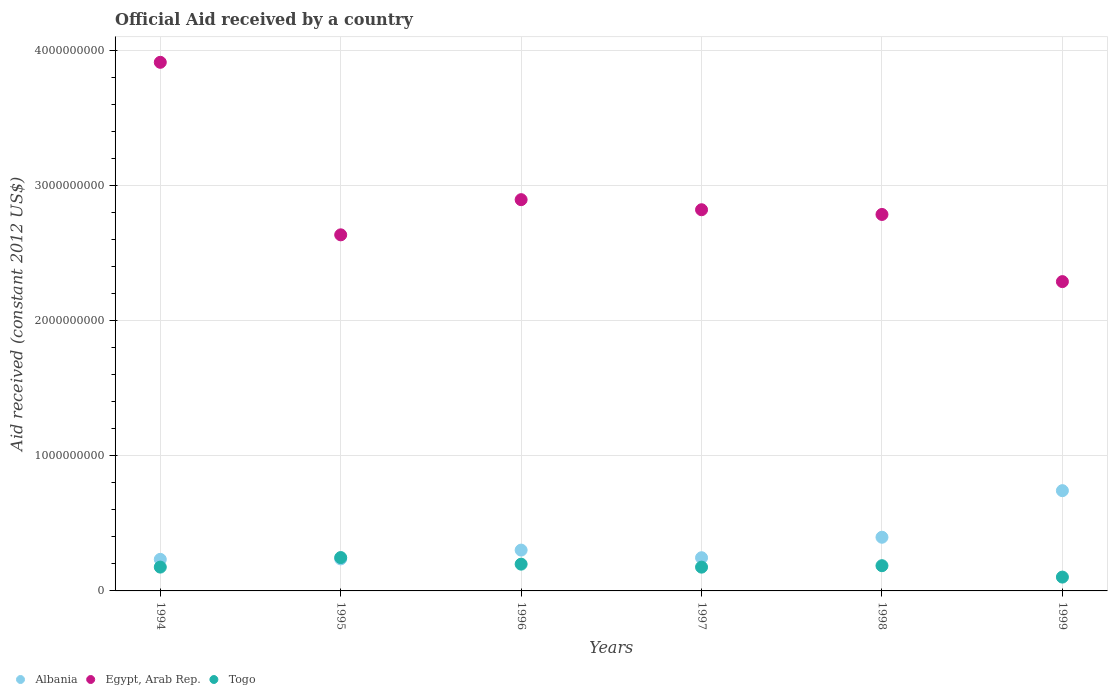How many different coloured dotlines are there?
Give a very brief answer. 3. What is the net official aid received in Togo in 1998?
Provide a short and direct response. 1.87e+08. Across all years, what is the maximum net official aid received in Egypt, Arab Rep.?
Your answer should be compact. 3.91e+09. Across all years, what is the minimum net official aid received in Albania?
Provide a short and direct response. 2.33e+08. In which year was the net official aid received in Albania maximum?
Ensure brevity in your answer.  1999. What is the total net official aid received in Egypt, Arab Rep. in the graph?
Give a very brief answer. 1.73e+1. What is the difference between the net official aid received in Togo in 1994 and that in 1995?
Make the answer very short. -7.06e+07. What is the difference between the net official aid received in Togo in 1997 and the net official aid received in Egypt, Arab Rep. in 1999?
Offer a very short reply. -2.11e+09. What is the average net official aid received in Albania per year?
Offer a very short reply. 3.59e+08. In the year 1994, what is the difference between the net official aid received in Albania and net official aid received in Egypt, Arab Rep.?
Offer a terse response. -3.68e+09. In how many years, is the net official aid received in Albania greater than 1600000000 US$?
Your answer should be compact. 0. What is the ratio of the net official aid received in Albania in 1997 to that in 1998?
Offer a very short reply. 0.62. Is the net official aid received in Egypt, Arab Rep. in 1995 less than that in 1999?
Provide a short and direct response. No. Is the difference between the net official aid received in Albania in 1995 and 1999 greater than the difference between the net official aid received in Egypt, Arab Rep. in 1995 and 1999?
Give a very brief answer. No. What is the difference between the highest and the second highest net official aid received in Egypt, Arab Rep.?
Offer a very short reply. 1.02e+09. What is the difference between the highest and the lowest net official aid received in Togo?
Your response must be concise. 1.44e+08. Is the sum of the net official aid received in Albania in 1995 and 1996 greater than the maximum net official aid received in Togo across all years?
Offer a terse response. Yes. Is it the case that in every year, the sum of the net official aid received in Albania and net official aid received in Egypt, Arab Rep.  is greater than the net official aid received in Togo?
Provide a short and direct response. Yes. Is the net official aid received in Egypt, Arab Rep. strictly greater than the net official aid received in Albania over the years?
Ensure brevity in your answer.  Yes. How many dotlines are there?
Offer a very short reply. 3. How many years are there in the graph?
Give a very brief answer. 6. Are the values on the major ticks of Y-axis written in scientific E-notation?
Your response must be concise. No. Does the graph contain any zero values?
Give a very brief answer. No. Does the graph contain grids?
Give a very brief answer. Yes. How many legend labels are there?
Provide a short and direct response. 3. How are the legend labels stacked?
Your response must be concise. Horizontal. What is the title of the graph?
Give a very brief answer. Official Aid received by a country. What is the label or title of the X-axis?
Make the answer very short. Years. What is the label or title of the Y-axis?
Ensure brevity in your answer.  Aid received (constant 2012 US$). What is the Aid received (constant 2012 US$) of Albania in 1994?
Your answer should be compact. 2.33e+08. What is the Aid received (constant 2012 US$) of Egypt, Arab Rep. in 1994?
Provide a short and direct response. 3.91e+09. What is the Aid received (constant 2012 US$) of Togo in 1994?
Your answer should be compact. 1.76e+08. What is the Aid received (constant 2012 US$) of Albania in 1995?
Offer a very short reply. 2.37e+08. What is the Aid received (constant 2012 US$) in Egypt, Arab Rep. in 1995?
Offer a very short reply. 2.63e+09. What is the Aid received (constant 2012 US$) in Togo in 1995?
Offer a terse response. 2.47e+08. What is the Aid received (constant 2012 US$) in Albania in 1996?
Provide a short and direct response. 3.02e+08. What is the Aid received (constant 2012 US$) in Egypt, Arab Rep. in 1996?
Make the answer very short. 2.89e+09. What is the Aid received (constant 2012 US$) in Togo in 1996?
Offer a terse response. 1.98e+08. What is the Aid received (constant 2012 US$) in Albania in 1997?
Make the answer very short. 2.46e+08. What is the Aid received (constant 2012 US$) of Egypt, Arab Rep. in 1997?
Your answer should be compact. 2.82e+09. What is the Aid received (constant 2012 US$) of Togo in 1997?
Ensure brevity in your answer.  1.76e+08. What is the Aid received (constant 2012 US$) in Albania in 1998?
Give a very brief answer. 3.97e+08. What is the Aid received (constant 2012 US$) in Egypt, Arab Rep. in 1998?
Your response must be concise. 2.78e+09. What is the Aid received (constant 2012 US$) of Togo in 1998?
Your answer should be very brief. 1.87e+08. What is the Aid received (constant 2012 US$) of Albania in 1999?
Offer a very short reply. 7.41e+08. What is the Aid received (constant 2012 US$) in Egypt, Arab Rep. in 1999?
Offer a terse response. 2.29e+09. What is the Aid received (constant 2012 US$) in Togo in 1999?
Keep it short and to the point. 1.02e+08. Across all years, what is the maximum Aid received (constant 2012 US$) in Albania?
Keep it short and to the point. 7.41e+08. Across all years, what is the maximum Aid received (constant 2012 US$) in Egypt, Arab Rep.?
Your answer should be very brief. 3.91e+09. Across all years, what is the maximum Aid received (constant 2012 US$) of Togo?
Your answer should be very brief. 2.47e+08. Across all years, what is the minimum Aid received (constant 2012 US$) of Albania?
Offer a very short reply. 2.33e+08. Across all years, what is the minimum Aid received (constant 2012 US$) in Egypt, Arab Rep.?
Make the answer very short. 2.29e+09. Across all years, what is the minimum Aid received (constant 2012 US$) in Togo?
Your answer should be compact. 1.02e+08. What is the total Aid received (constant 2012 US$) in Albania in the graph?
Your answer should be very brief. 2.16e+09. What is the total Aid received (constant 2012 US$) of Egypt, Arab Rep. in the graph?
Offer a terse response. 1.73e+1. What is the total Aid received (constant 2012 US$) in Togo in the graph?
Offer a very short reply. 1.09e+09. What is the difference between the Aid received (constant 2012 US$) of Albania in 1994 and that in 1995?
Provide a short and direct response. -3.44e+06. What is the difference between the Aid received (constant 2012 US$) in Egypt, Arab Rep. in 1994 and that in 1995?
Give a very brief answer. 1.28e+09. What is the difference between the Aid received (constant 2012 US$) of Togo in 1994 and that in 1995?
Offer a very short reply. -7.06e+07. What is the difference between the Aid received (constant 2012 US$) of Albania in 1994 and that in 1996?
Provide a succinct answer. -6.84e+07. What is the difference between the Aid received (constant 2012 US$) in Egypt, Arab Rep. in 1994 and that in 1996?
Offer a very short reply. 1.02e+09. What is the difference between the Aid received (constant 2012 US$) in Togo in 1994 and that in 1996?
Provide a short and direct response. -2.18e+07. What is the difference between the Aid received (constant 2012 US$) of Albania in 1994 and that in 1997?
Your answer should be very brief. -1.21e+07. What is the difference between the Aid received (constant 2012 US$) of Egypt, Arab Rep. in 1994 and that in 1997?
Provide a short and direct response. 1.09e+09. What is the difference between the Aid received (constant 2012 US$) of Albania in 1994 and that in 1998?
Offer a terse response. -1.64e+08. What is the difference between the Aid received (constant 2012 US$) in Egypt, Arab Rep. in 1994 and that in 1998?
Offer a very short reply. 1.13e+09. What is the difference between the Aid received (constant 2012 US$) in Togo in 1994 and that in 1998?
Provide a short and direct response. -1.04e+07. What is the difference between the Aid received (constant 2012 US$) in Albania in 1994 and that in 1999?
Provide a short and direct response. -5.08e+08. What is the difference between the Aid received (constant 2012 US$) in Egypt, Arab Rep. in 1994 and that in 1999?
Ensure brevity in your answer.  1.62e+09. What is the difference between the Aid received (constant 2012 US$) of Togo in 1994 and that in 1999?
Provide a succinct answer. 7.39e+07. What is the difference between the Aid received (constant 2012 US$) in Albania in 1995 and that in 1996?
Offer a very short reply. -6.50e+07. What is the difference between the Aid received (constant 2012 US$) of Egypt, Arab Rep. in 1995 and that in 1996?
Offer a terse response. -2.60e+08. What is the difference between the Aid received (constant 2012 US$) in Togo in 1995 and that in 1996?
Keep it short and to the point. 4.87e+07. What is the difference between the Aid received (constant 2012 US$) in Albania in 1995 and that in 1997?
Ensure brevity in your answer.  -8.68e+06. What is the difference between the Aid received (constant 2012 US$) in Egypt, Arab Rep. in 1995 and that in 1997?
Offer a terse response. -1.86e+08. What is the difference between the Aid received (constant 2012 US$) of Togo in 1995 and that in 1997?
Provide a succinct answer. 7.09e+07. What is the difference between the Aid received (constant 2012 US$) of Albania in 1995 and that in 1998?
Provide a short and direct response. -1.60e+08. What is the difference between the Aid received (constant 2012 US$) of Egypt, Arab Rep. in 1995 and that in 1998?
Make the answer very short. -1.51e+08. What is the difference between the Aid received (constant 2012 US$) of Togo in 1995 and that in 1998?
Keep it short and to the point. 6.02e+07. What is the difference between the Aid received (constant 2012 US$) in Albania in 1995 and that in 1999?
Your response must be concise. -5.05e+08. What is the difference between the Aid received (constant 2012 US$) of Egypt, Arab Rep. in 1995 and that in 1999?
Offer a terse response. 3.46e+08. What is the difference between the Aid received (constant 2012 US$) in Togo in 1995 and that in 1999?
Ensure brevity in your answer.  1.44e+08. What is the difference between the Aid received (constant 2012 US$) in Albania in 1996 and that in 1997?
Ensure brevity in your answer.  5.63e+07. What is the difference between the Aid received (constant 2012 US$) in Egypt, Arab Rep. in 1996 and that in 1997?
Your answer should be very brief. 7.45e+07. What is the difference between the Aid received (constant 2012 US$) in Togo in 1996 and that in 1997?
Ensure brevity in your answer.  2.22e+07. What is the difference between the Aid received (constant 2012 US$) in Albania in 1996 and that in 1998?
Your answer should be very brief. -9.51e+07. What is the difference between the Aid received (constant 2012 US$) in Egypt, Arab Rep. in 1996 and that in 1998?
Your answer should be very brief. 1.09e+08. What is the difference between the Aid received (constant 2012 US$) of Togo in 1996 and that in 1998?
Make the answer very short. 1.15e+07. What is the difference between the Aid received (constant 2012 US$) of Albania in 1996 and that in 1999?
Give a very brief answer. -4.40e+08. What is the difference between the Aid received (constant 2012 US$) of Egypt, Arab Rep. in 1996 and that in 1999?
Provide a succinct answer. 6.06e+08. What is the difference between the Aid received (constant 2012 US$) in Togo in 1996 and that in 1999?
Offer a terse response. 9.57e+07. What is the difference between the Aid received (constant 2012 US$) of Albania in 1997 and that in 1998?
Your response must be concise. -1.51e+08. What is the difference between the Aid received (constant 2012 US$) in Egypt, Arab Rep. in 1997 and that in 1998?
Provide a succinct answer. 3.49e+07. What is the difference between the Aid received (constant 2012 US$) of Togo in 1997 and that in 1998?
Ensure brevity in your answer.  -1.07e+07. What is the difference between the Aid received (constant 2012 US$) of Albania in 1997 and that in 1999?
Your answer should be very brief. -4.96e+08. What is the difference between the Aid received (constant 2012 US$) in Egypt, Arab Rep. in 1997 and that in 1999?
Keep it short and to the point. 5.32e+08. What is the difference between the Aid received (constant 2012 US$) in Togo in 1997 and that in 1999?
Provide a short and direct response. 7.36e+07. What is the difference between the Aid received (constant 2012 US$) in Albania in 1998 and that in 1999?
Your response must be concise. -3.44e+08. What is the difference between the Aid received (constant 2012 US$) in Egypt, Arab Rep. in 1998 and that in 1999?
Provide a short and direct response. 4.97e+08. What is the difference between the Aid received (constant 2012 US$) in Togo in 1998 and that in 1999?
Provide a short and direct response. 8.43e+07. What is the difference between the Aid received (constant 2012 US$) of Albania in 1994 and the Aid received (constant 2012 US$) of Egypt, Arab Rep. in 1995?
Provide a succinct answer. -2.40e+09. What is the difference between the Aid received (constant 2012 US$) in Albania in 1994 and the Aid received (constant 2012 US$) in Togo in 1995?
Your response must be concise. -1.33e+07. What is the difference between the Aid received (constant 2012 US$) in Egypt, Arab Rep. in 1994 and the Aid received (constant 2012 US$) in Togo in 1995?
Your answer should be compact. 3.66e+09. What is the difference between the Aid received (constant 2012 US$) in Albania in 1994 and the Aid received (constant 2012 US$) in Egypt, Arab Rep. in 1996?
Provide a succinct answer. -2.66e+09. What is the difference between the Aid received (constant 2012 US$) in Albania in 1994 and the Aid received (constant 2012 US$) in Togo in 1996?
Keep it short and to the point. 3.54e+07. What is the difference between the Aid received (constant 2012 US$) in Egypt, Arab Rep. in 1994 and the Aid received (constant 2012 US$) in Togo in 1996?
Your answer should be compact. 3.71e+09. What is the difference between the Aid received (constant 2012 US$) of Albania in 1994 and the Aid received (constant 2012 US$) of Egypt, Arab Rep. in 1997?
Your answer should be compact. -2.59e+09. What is the difference between the Aid received (constant 2012 US$) in Albania in 1994 and the Aid received (constant 2012 US$) in Togo in 1997?
Make the answer very short. 5.76e+07. What is the difference between the Aid received (constant 2012 US$) in Egypt, Arab Rep. in 1994 and the Aid received (constant 2012 US$) in Togo in 1997?
Your answer should be very brief. 3.73e+09. What is the difference between the Aid received (constant 2012 US$) of Albania in 1994 and the Aid received (constant 2012 US$) of Egypt, Arab Rep. in 1998?
Provide a succinct answer. -2.55e+09. What is the difference between the Aid received (constant 2012 US$) of Albania in 1994 and the Aid received (constant 2012 US$) of Togo in 1998?
Your answer should be compact. 4.69e+07. What is the difference between the Aid received (constant 2012 US$) in Egypt, Arab Rep. in 1994 and the Aid received (constant 2012 US$) in Togo in 1998?
Keep it short and to the point. 3.72e+09. What is the difference between the Aid received (constant 2012 US$) in Albania in 1994 and the Aid received (constant 2012 US$) in Egypt, Arab Rep. in 1999?
Provide a succinct answer. -2.05e+09. What is the difference between the Aid received (constant 2012 US$) of Albania in 1994 and the Aid received (constant 2012 US$) of Togo in 1999?
Give a very brief answer. 1.31e+08. What is the difference between the Aid received (constant 2012 US$) of Egypt, Arab Rep. in 1994 and the Aid received (constant 2012 US$) of Togo in 1999?
Offer a very short reply. 3.81e+09. What is the difference between the Aid received (constant 2012 US$) of Albania in 1995 and the Aid received (constant 2012 US$) of Egypt, Arab Rep. in 1996?
Your answer should be compact. -2.66e+09. What is the difference between the Aid received (constant 2012 US$) of Albania in 1995 and the Aid received (constant 2012 US$) of Togo in 1996?
Provide a succinct answer. 3.88e+07. What is the difference between the Aid received (constant 2012 US$) of Egypt, Arab Rep. in 1995 and the Aid received (constant 2012 US$) of Togo in 1996?
Give a very brief answer. 2.44e+09. What is the difference between the Aid received (constant 2012 US$) in Albania in 1995 and the Aid received (constant 2012 US$) in Egypt, Arab Rep. in 1997?
Give a very brief answer. -2.58e+09. What is the difference between the Aid received (constant 2012 US$) in Albania in 1995 and the Aid received (constant 2012 US$) in Togo in 1997?
Your answer should be compact. 6.10e+07. What is the difference between the Aid received (constant 2012 US$) in Egypt, Arab Rep. in 1995 and the Aid received (constant 2012 US$) in Togo in 1997?
Keep it short and to the point. 2.46e+09. What is the difference between the Aid received (constant 2012 US$) of Albania in 1995 and the Aid received (constant 2012 US$) of Egypt, Arab Rep. in 1998?
Provide a succinct answer. -2.55e+09. What is the difference between the Aid received (constant 2012 US$) in Albania in 1995 and the Aid received (constant 2012 US$) in Togo in 1998?
Make the answer very short. 5.03e+07. What is the difference between the Aid received (constant 2012 US$) of Egypt, Arab Rep. in 1995 and the Aid received (constant 2012 US$) of Togo in 1998?
Your answer should be very brief. 2.45e+09. What is the difference between the Aid received (constant 2012 US$) in Albania in 1995 and the Aid received (constant 2012 US$) in Egypt, Arab Rep. in 1999?
Ensure brevity in your answer.  -2.05e+09. What is the difference between the Aid received (constant 2012 US$) of Albania in 1995 and the Aid received (constant 2012 US$) of Togo in 1999?
Offer a terse response. 1.35e+08. What is the difference between the Aid received (constant 2012 US$) in Egypt, Arab Rep. in 1995 and the Aid received (constant 2012 US$) in Togo in 1999?
Provide a short and direct response. 2.53e+09. What is the difference between the Aid received (constant 2012 US$) in Albania in 1996 and the Aid received (constant 2012 US$) in Egypt, Arab Rep. in 1997?
Your answer should be very brief. -2.52e+09. What is the difference between the Aid received (constant 2012 US$) of Albania in 1996 and the Aid received (constant 2012 US$) of Togo in 1997?
Offer a very short reply. 1.26e+08. What is the difference between the Aid received (constant 2012 US$) of Egypt, Arab Rep. in 1996 and the Aid received (constant 2012 US$) of Togo in 1997?
Give a very brief answer. 2.72e+09. What is the difference between the Aid received (constant 2012 US$) of Albania in 1996 and the Aid received (constant 2012 US$) of Egypt, Arab Rep. in 1998?
Offer a terse response. -2.48e+09. What is the difference between the Aid received (constant 2012 US$) of Albania in 1996 and the Aid received (constant 2012 US$) of Togo in 1998?
Offer a very short reply. 1.15e+08. What is the difference between the Aid received (constant 2012 US$) of Egypt, Arab Rep. in 1996 and the Aid received (constant 2012 US$) of Togo in 1998?
Give a very brief answer. 2.71e+09. What is the difference between the Aid received (constant 2012 US$) in Albania in 1996 and the Aid received (constant 2012 US$) in Egypt, Arab Rep. in 1999?
Your response must be concise. -1.99e+09. What is the difference between the Aid received (constant 2012 US$) of Albania in 1996 and the Aid received (constant 2012 US$) of Togo in 1999?
Your answer should be compact. 2.00e+08. What is the difference between the Aid received (constant 2012 US$) of Egypt, Arab Rep. in 1996 and the Aid received (constant 2012 US$) of Togo in 1999?
Offer a terse response. 2.79e+09. What is the difference between the Aid received (constant 2012 US$) of Albania in 1997 and the Aid received (constant 2012 US$) of Egypt, Arab Rep. in 1998?
Give a very brief answer. -2.54e+09. What is the difference between the Aid received (constant 2012 US$) of Albania in 1997 and the Aid received (constant 2012 US$) of Togo in 1998?
Offer a very short reply. 5.90e+07. What is the difference between the Aid received (constant 2012 US$) of Egypt, Arab Rep. in 1997 and the Aid received (constant 2012 US$) of Togo in 1998?
Your answer should be very brief. 2.63e+09. What is the difference between the Aid received (constant 2012 US$) in Albania in 1997 and the Aid received (constant 2012 US$) in Egypt, Arab Rep. in 1999?
Ensure brevity in your answer.  -2.04e+09. What is the difference between the Aid received (constant 2012 US$) in Albania in 1997 and the Aid received (constant 2012 US$) in Togo in 1999?
Keep it short and to the point. 1.43e+08. What is the difference between the Aid received (constant 2012 US$) in Egypt, Arab Rep. in 1997 and the Aid received (constant 2012 US$) in Togo in 1999?
Provide a short and direct response. 2.72e+09. What is the difference between the Aid received (constant 2012 US$) of Albania in 1998 and the Aid received (constant 2012 US$) of Egypt, Arab Rep. in 1999?
Provide a succinct answer. -1.89e+09. What is the difference between the Aid received (constant 2012 US$) in Albania in 1998 and the Aid received (constant 2012 US$) in Togo in 1999?
Make the answer very short. 2.95e+08. What is the difference between the Aid received (constant 2012 US$) in Egypt, Arab Rep. in 1998 and the Aid received (constant 2012 US$) in Togo in 1999?
Offer a very short reply. 2.68e+09. What is the average Aid received (constant 2012 US$) of Albania per year?
Give a very brief answer. 3.59e+08. What is the average Aid received (constant 2012 US$) of Egypt, Arab Rep. per year?
Your answer should be compact. 2.89e+09. What is the average Aid received (constant 2012 US$) of Togo per year?
Your answer should be compact. 1.81e+08. In the year 1994, what is the difference between the Aid received (constant 2012 US$) of Albania and Aid received (constant 2012 US$) of Egypt, Arab Rep.?
Offer a very short reply. -3.68e+09. In the year 1994, what is the difference between the Aid received (constant 2012 US$) in Albania and Aid received (constant 2012 US$) in Togo?
Keep it short and to the point. 5.72e+07. In the year 1994, what is the difference between the Aid received (constant 2012 US$) of Egypt, Arab Rep. and Aid received (constant 2012 US$) of Togo?
Offer a terse response. 3.73e+09. In the year 1995, what is the difference between the Aid received (constant 2012 US$) of Albania and Aid received (constant 2012 US$) of Egypt, Arab Rep.?
Provide a short and direct response. -2.40e+09. In the year 1995, what is the difference between the Aid received (constant 2012 US$) of Albania and Aid received (constant 2012 US$) of Togo?
Provide a short and direct response. -9.90e+06. In the year 1995, what is the difference between the Aid received (constant 2012 US$) of Egypt, Arab Rep. and Aid received (constant 2012 US$) of Togo?
Your answer should be compact. 2.39e+09. In the year 1996, what is the difference between the Aid received (constant 2012 US$) in Albania and Aid received (constant 2012 US$) in Egypt, Arab Rep.?
Your answer should be compact. -2.59e+09. In the year 1996, what is the difference between the Aid received (constant 2012 US$) of Albania and Aid received (constant 2012 US$) of Togo?
Give a very brief answer. 1.04e+08. In the year 1996, what is the difference between the Aid received (constant 2012 US$) of Egypt, Arab Rep. and Aid received (constant 2012 US$) of Togo?
Keep it short and to the point. 2.70e+09. In the year 1997, what is the difference between the Aid received (constant 2012 US$) of Albania and Aid received (constant 2012 US$) of Egypt, Arab Rep.?
Provide a short and direct response. -2.57e+09. In the year 1997, what is the difference between the Aid received (constant 2012 US$) in Albania and Aid received (constant 2012 US$) in Togo?
Ensure brevity in your answer.  6.97e+07. In the year 1997, what is the difference between the Aid received (constant 2012 US$) in Egypt, Arab Rep. and Aid received (constant 2012 US$) in Togo?
Give a very brief answer. 2.64e+09. In the year 1998, what is the difference between the Aid received (constant 2012 US$) of Albania and Aid received (constant 2012 US$) of Egypt, Arab Rep.?
Make the answer very short. -2.39e+09. In the year 1998, what is the difference between the Aid received (constant 2012 US$) in Albania and Aid received (constant 2012 US$) in Togo?
Make the answer very short. 2.10e+08. In the year 1998, what is the difference between the Aid received (constant 2012 US$) in Egypt, Arab Rep. and Aid received (constant 2012 US$) in Togo?
Your response must be concise. 2.60e+09. In the year 1999, what is the difference between the Aid received (constant 2012 US$) of Albania and Aid received (constant 2012 US$) of Egypt, Arab Rep.?
Ensure brevity in your answer.  -1.55e+09. In the year 1999, what is the difference between the Aid received (constant 2012 US$) of Albania and Aid received (constant 2012 US$) of Togo?
Give a very brief answer. 6.39e+08. In the year 1999, what is the difference between the Aid received (constant 2012 US$) of Egypt, Arab Rep. and Aid received (constant 2012 US$) of Togo?
Ensure brevity in your answer.  2.19e+09. What is the ratio of the Aid received (constant 2012 US$) in Albania in 1994 to that in 1995?
Provide a succinct answer. 0.99. What is the ratio of the Aid received (constant 2012 US$) of Egypt, Arab Rep. in 1994 to that in 1995?
Your answer should be very brief. 1.48. What is the ratio of the Aid received (constant 2012 US$) in Togo in 1994 to that in 1995?
Ensure brevity in your answer.  0.71. What is the ratio of the Aid received (constant 2012 US$) in Albania in 1994 to that in 1996?
Provide a short and direct response. 0.77. What is the ratio of the Aid received (constant 2012 US$) in Egypt, Arab Rep. in 1994 to that in 1996?
Offer a terse response. 1.35. What is the ratio of the Aid received (constant 2012 US$) in Togo in 1994 to that in 1996?
Give a very brief answer. 0.89. What is the ratio of the Aid received (constant 2012 US$) in Albania in 1994 to that in 1997?
Provide a short and direct response. 0.95. What is the ratio of the Aid received (constant 2012 US$) in Egypt, Arab Rep. in 1994 to that in 1997?
Your response must be concise. 1.39. What is the ratio of the Aid received (constant 2012 US$) in Togo in 1994 to that in 1997?
Make the answer very short. 1. What is the ratio of the Aid received (constant 2012 US$) of Albania in 1994 to that in 1998?
Keep it short and to the point. 0.59. What is the ratio of the Aid received (constant 2012 US$) of Egypt, Arab Rep. in 1994 to that in 1998?
Offer a very short reply. 1.4. What is the ratio of the Aid received (constant 2012 US$) in Togo in 1994 to that in 1998?
Provide a succinct answer. 0.94. What is the ratio of the Aid received (constant 2012 US$) of Albania in 1994 to that in 1999?
Offer a very short reply. 0.31. What is the ratio of the Aid received (constant 2012 US$) in Egypt, Arab Rep. in 1994 to that in 1999?
Offer a terse response. 1.71. What is the ratio of the Aid received (constant 2012 US$) of Togo in 1994 to that in 1999?
Make the answer very short. 1.72. What is the ratio of the Aid received (constant 2012 US$) of Albania in 1995 to that in 1996?
Your answer should be very brief. 0.78. What is the ratio of the Aid received (constant 2012 US$) of Egypt, Arab Rep. in 1995 to that in 1996?
Offer a very short reply. 0.91. What is the ratio of the Aid received (constant 2012 US$) in Togo in 1995 to that in 1996?
Offer a terse response. 1.25. What is the ratio of the Aid received (constant 2012 US$) of Albania in 1995 to that in 1997?
Give a very brief answer. 0.96. What is the ratio of the Aid received (constant 2012 US$) of Egypt, Arab Rep. in 1995 to that in 1997?
Give a very brief answer. 0.93. What is the ratio of the Aid received (constant 2012 US$) in Togo in 1995 to that in 1997?
Offer a very short reply. 1.4. What is the ratio of the Aid received (constant 2012 US$) in Albania in 1995 to that in 1998?
Make the answer very short. 0.6. What is the ratio of the Aid received (constant 2012 US$) of Egypt, Arab Rep. in 1995 to that in 1998?
Make the answer very short. 0.95. What is the ratio of the Aid received (constant 2012 US$) of Togo in 1995 to that in 1998?
Ensure brevity in your answer.  1.32. What is the ratio of the Aid received (constant 2012 US$) of Albania in 1995 to that in 1999?
Your answer should be compact. 0.32. What is the ratio of the Aid received (constant 2012 US$) in Egypt, Arab Rep. in 1995 to that in 1999?
Keep it short and to the point. 1.15. What is the ratio of the Aid received (constant 2012 US$) in Togo in 1995 to that in 1999?
Your answer should be very brief. 2.41. What is the ratio of the Aid received (constant 2012 US$) of Albania in 1996 to that in 1997?
Make the answer very short. 1.23. What is the ratio of the Aid received (constant 2012 US$) of Egypt, Arab Rep. in 1996 to that in 1997?
Your response must be concise. 1.03. What is the ratio of the Aid received (constant 2012 US$) of Togo in 1996 to that in 1997?
Offer a very short reply. 1.13. What is the ratio of the Aid received (constant 2012 US$) of Albania in 1996 to that in 1998?
Provide a succinct answer. 0.76. What is the ratio of the Aid received (constant 2012 US$) of Egypt, Arab Rep. in 1996 to that in 1998?
Give a very brief answer. 1.04. What is the ratio of the Aid received (constant 2012 US$) in Togo in 1996 to that in 1998?
Keep it short and to the point. 1.06. What is the ratio of the Aid received (constant 2012 US$) in Albania in 1996 to that in 1999?
Offer a very short reply. 0.41. What is the ratio of the Aid received (constant 2012 US$) in Egypt, Arab Rep. in 1996 to that in 1999?
Your response must be concise. 1.26. What is the ratio of the Aid received (constant 2012 US$) of Togo in 1996 to that in 1999?
Provide a succinct answer. 1.94. What is the ratio of the Aid received (constant 2012 US$) in Albania in 1997 to that in 1998?
Your answer should be very brief. 0.62. What is the ratio of the Aid received (constant 2012 US$) of Egypt, Arab Rep. in 1997 to that in 1998?
Offer a terse response. 1.01. What is the ratio of the Aid received (constant 2012 US$) in Togo in 1997 to that in 1998?
Your response must be concise. 0.94. What is the ratio of the Aid received (constant 2012 US$) of Albania in 1997 to that in 1999?
Your answer should be compact. 0.33. What is the ratio of the Aid received (constant 2012 US$) of Egypt, Arab Rep. in 1997 to that in 1999?
Provide a short and direct response. 1.23. What is the ratio of the Aid received (constant 2012 US$) in Togo in 1997 to that in 1999?
Ensure brevity in your answer.  1.72. What is the ratio of the Aid received (constant 2012 US$) in Albania in 1998 to that in 1999?
Offer a terse response. 0.54. What is the ratio of the Aid received (constant 2012 US$) of Egypt, Arab Rep. in 1998 to that in 1999?
Provide a short and direct response. 1.22. What is the ratio of the Aid received (constant 2012 US$) of Togo in 1998 to that in 1999?
Your answer should be compact. 1.82. What is the difference between the highest and the second highest Aid received (constant 2012 US$) in Albania?
Your response must be concise. 3.44e+08. What is the difference between the highest and the second highest Aid received (constant 2012 US$) in Egypt, Arab Rep.?
Give a very brief answer. 1.02e+09. What is the difference between the highest and the second highest Aid received (constant 2012 US$) of Togo?
Provide a succinct answer. 4.87e+07. What is the difference between the highest and the lowest Aid received (constant 2012 US$) in Albania?
Give a very brief answer. 5.08e+08. What is the difference between the highest and the lowest Aid received (constant 2012 US$) of Egypt, Arab Rep.?
Give a very brief answer. 1.62e+09. What is the difference between the highest and the lowest Aid received (constant 2012 US$) of Togo?
Your response must be concise. 1.44e+08. 